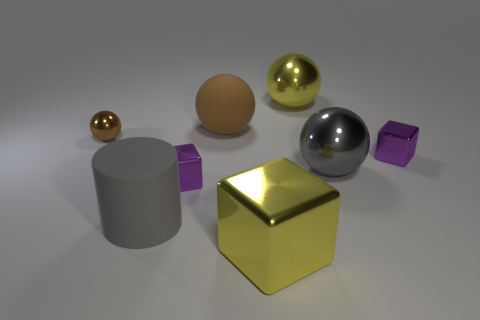Are there any other things that are the same shape as the big gray rubber object?
Make the answer very short. No. There is a matte sphere; does it have the same color as the metal sphere on the left side of the brown rubber object?
Provide a succinct answer. Yes. How many small matte cubes have the same color as the large matte ball?
Offer a terse response. 0. What is the shape of the tiny brown object that is made of the same material as the large gray sphere?
Offer a terse response. Sphere. How big is the gray object to the left of the yellow block?
Offer a very short reply. Large. Is the number of big rubber things in front of the big cube the same as the number of purple shiny objects behind the gray metal sphere?
Offer a very short reply. No. What color is the object in front of the large gray thing in front of the tiny metal block on the left side of the big brown rubber sphere?
Your answer should be very brief. Yellow. What number of big metallic things are both behind the big gray cylinder and in front of the tiny brown sphere?
Keep it short and to the point. 1. There is a big ball right of the big yellow shiny sphere; is its color the same as the large matte object in front of the big gray metallic thing?
Your answer should be compact. Yes. What size is the yellow metal thing that is the same shape as the big gray metal object?
Provide a succinct answer. Large. 